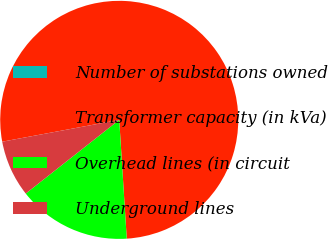Convert chart. <chart><loc_0><loc_0><loc_500><loc_500><pie_chart><fcel>Number of substations owned<fcel>Transformer capacity (in kVa)<fcel>Overhead lines (in circuit<fcel>Underground lines<nl><fcel>0.0%<fcel>76.92%<fcel>15.38%<fcel>7.69%<nl></chart> 